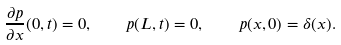Convert formula to latex. <formula><loc_0><loc_0><loc_500><loc_500>\frac { \partial p } { \partial x } ( 0 , t ) = 0 , \quad p ( L , t ) = 0 , \quad p ( x , 0 ) = \delta ( x ) .</formula> 